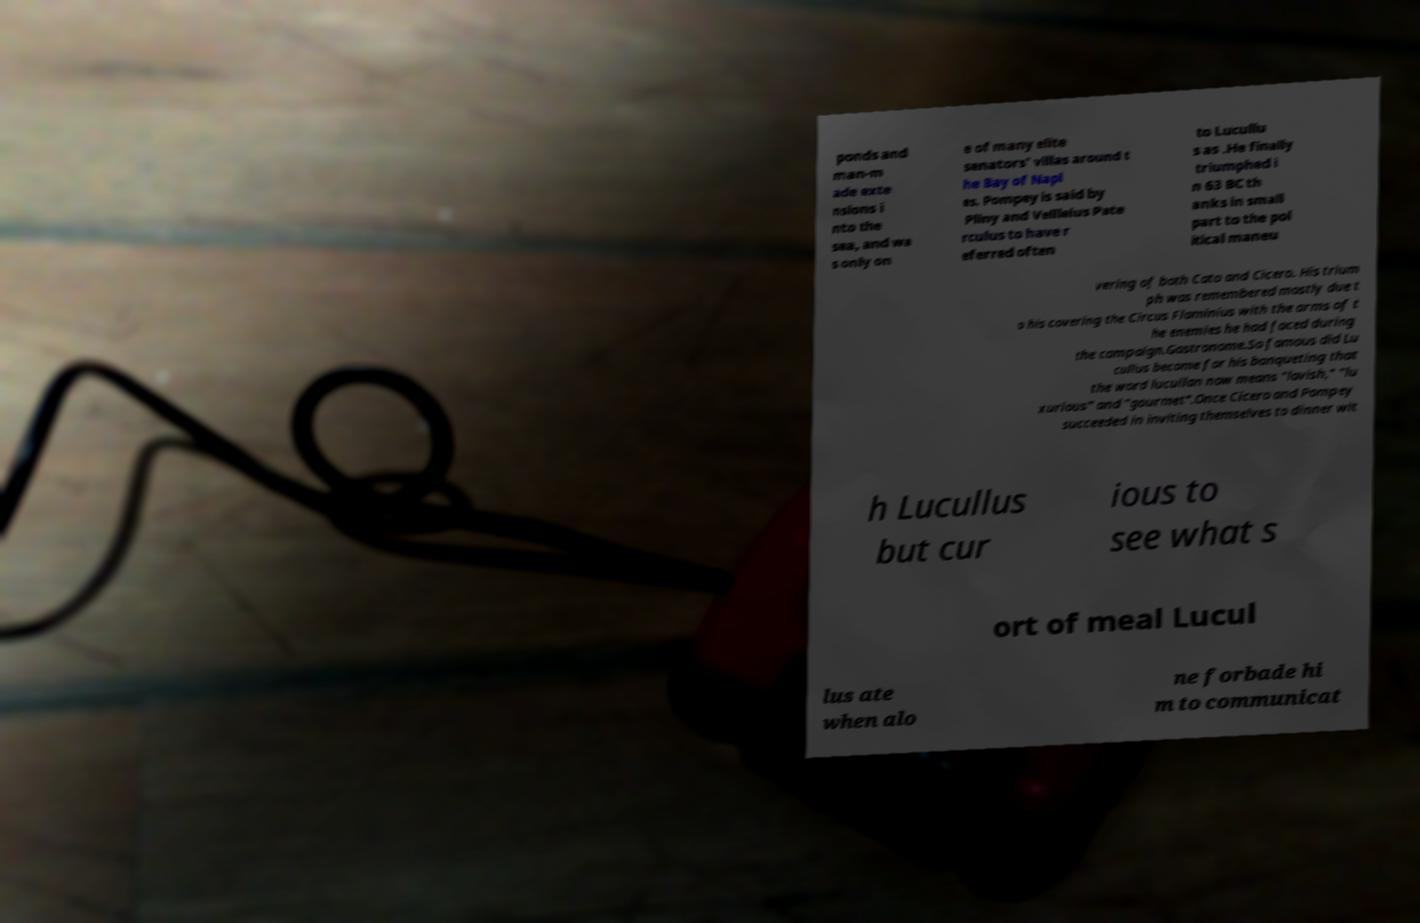Could you extract and type out the text from this image? ponds and man-m ade exte nsions i nto the sea, and wa s only on e of many elite senators' villas around t he Bay of Napl es. Pompey is said by Pliny and Vellleius Pate rculus to have r eferred often to Lucullu s as .He finally triumphed i n 63 BC th anks in small part to the pol itical maneu vering of both Cato and Cicero. His trium ph was remembered mostly due t o his covering the Circus Flaminius with the arms of t he enemies he had faced during the campaign.Gastronome.So famous did Lu cullus become for his banqueting that the word lucullan now means "lavish," "lu xurious" and "gourmet".Once Cicero and Pompey succeeded in inviting themselves to dinner wit h Lucullus but cur ious to see what s ort of meal Lucul lus ate when alo ne forbade hi m to communicat 